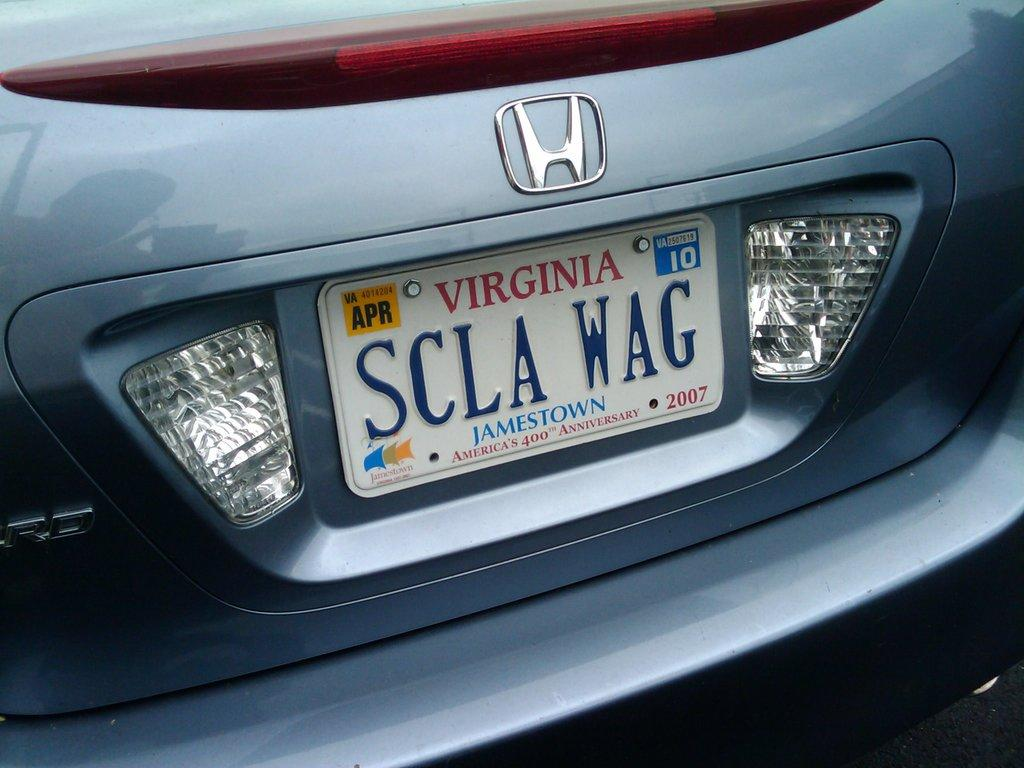<image>
Summarize the visual content of the image. Honda car that includes a Jamestown Virginia tag 